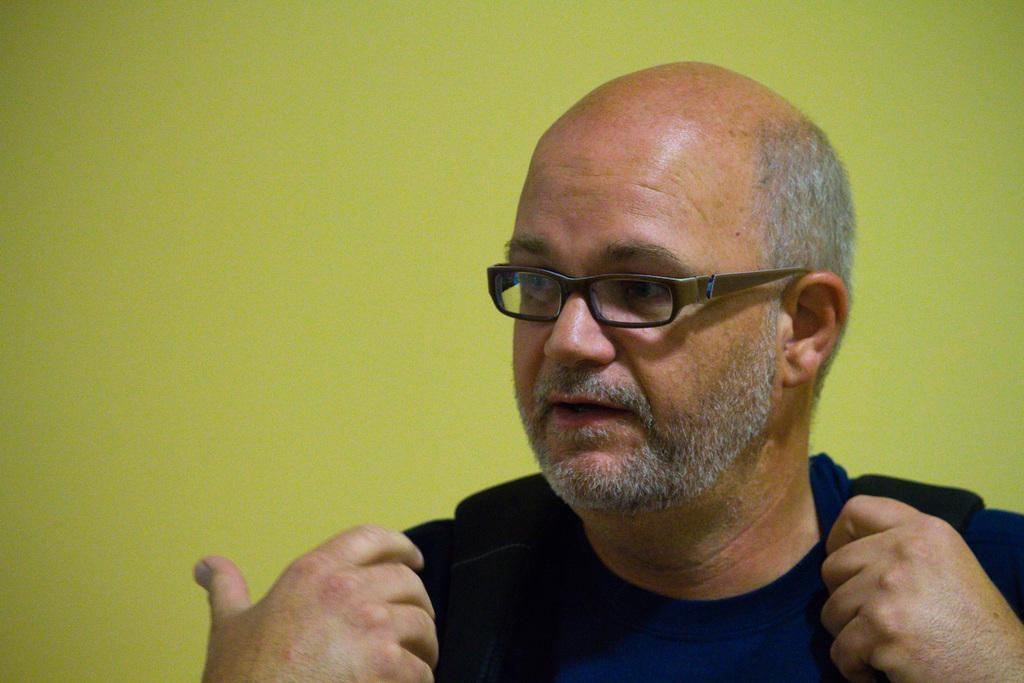What is the appearance of the man in the image? There is a bald-headed old man in the image. What is the man wearing in the image? The man is wearing a black dress and spectacles. What color is the wall behind the man in the image? There is a yellow wall in the image. Where is the man standing in relation to the wall? The man is standing behind the yellow wall. What type of ink is the man using to write on the wall in the image? There is no indication in the image that the man is using ink or writing on the wall. 